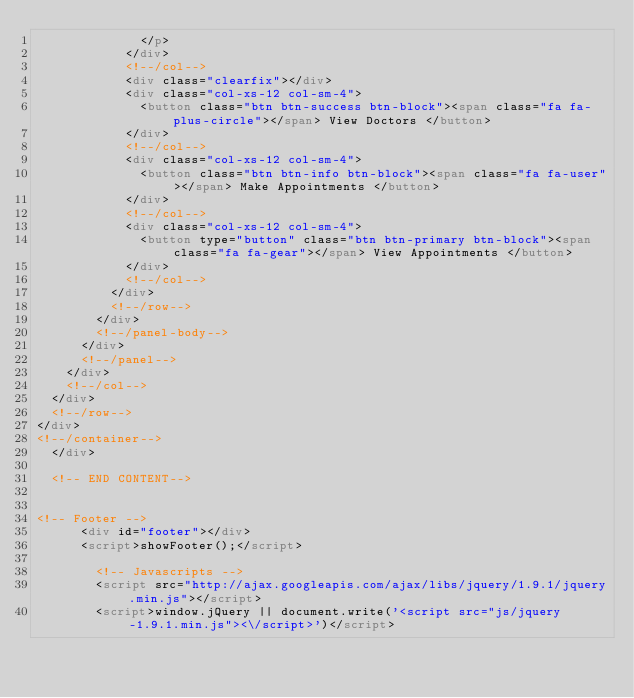Convert code to text. <code><loc_0><loc_0><loc_500><loc_500><_HTML_>              </p>
            </div>
            <!--/col-->          
            <div class="clearfix"></div>
            <div class="col-xs-12 col-sm-4">
              <button class="btn btn-success btn-block"><span class="fa fa-plus-circle"></span> View Doctors </button>
            </div>
            <!--/col-->
            <div class="col-xs-12 col-sm-4">
              <button class="btn btn-info btn-block"><span class="fa fa-user"></span> Make Appointments </button>
            </div>
            <!--/col-->
            <div class="col-xs-12 col-sm-4">
              <button type="button" class="btn btn-primary btn-block"><span class="fa fa-gear"></span> View Appointments </button>  
            </div>
            <!--/col-->
          </div>
          <!--/row-->
        </div>
        <!--/panel-body-->
      </div>
      <!--/panel-->
    </div>
    <!--/col--> 
  </div>
  <!--/row--> 
</div>
<!--/container-->	
	</div>
	
	<!-- END CONTENT-->


<!-- Footer -->
	    <div id="footer"></div>
	    <script>showFooter();</script>

        <!-- Javascripts -->
        <script src="http://ajax.googleapis.com/ajax/libs/jquery/1.9.1/jquery.min.js"></script>
        <script>window.jQuery || document.write('<script src="js/jquery-1.9.1.min.js"><\/script>')</script></code> 